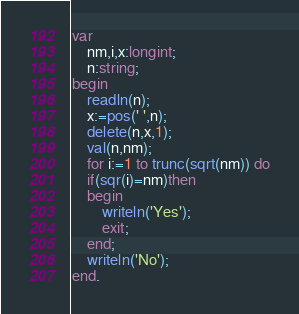<code> <loc_0><loc_0><loc_500><loc_500><_Pascal_>var
    nm,i,x:longint;
    n:string;
begin
    readln(n);
    x:=pos(' ',n);
    delete(n,x,1);
    val(n,nm);
    for i:=1 to trunc(sqrt(nm)) do
    if(sqr(i)=nm)then
    begin
        writeln('Yes');
        exit;
    end;
    writeln('No');
end.</code> 